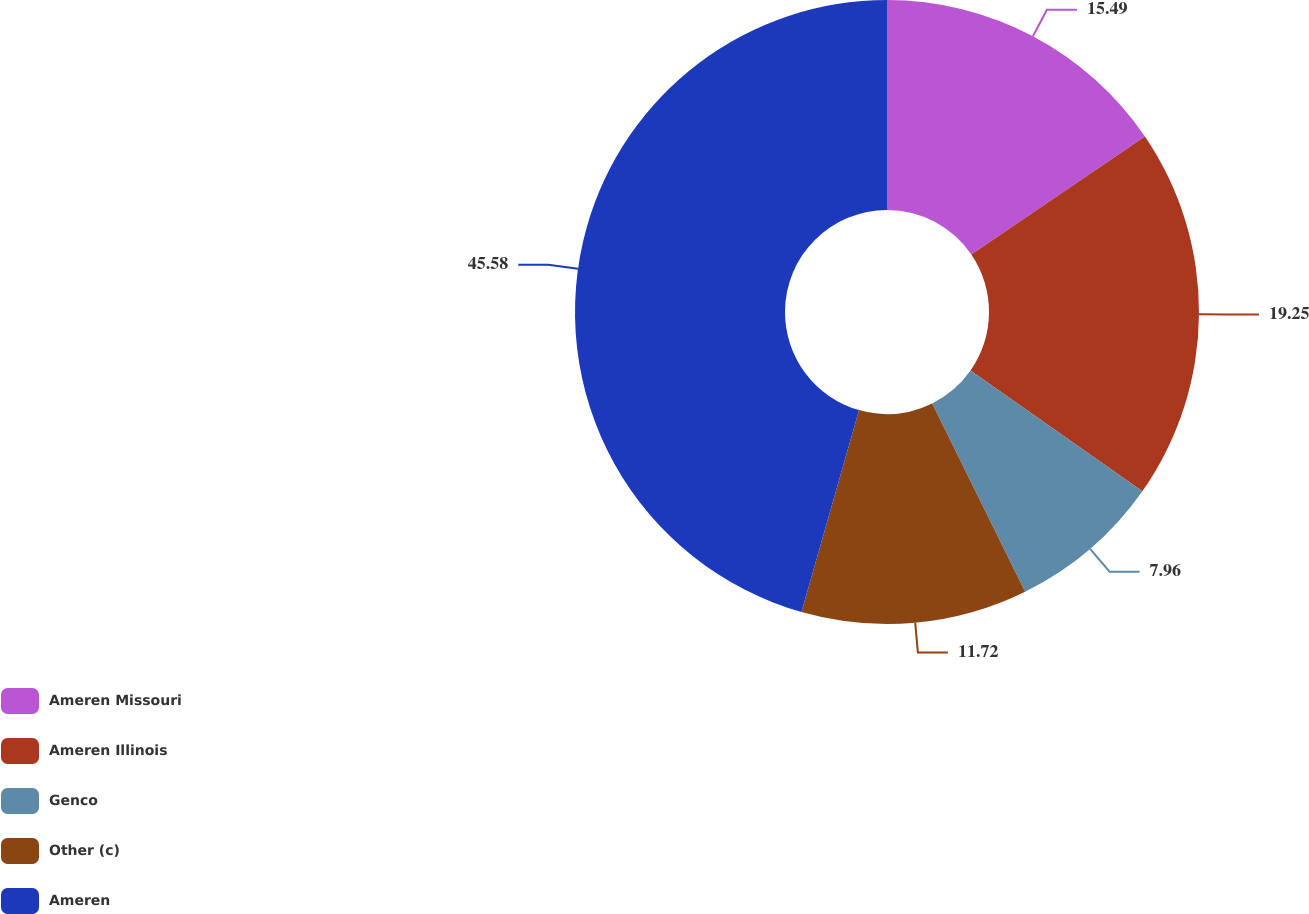Convert chart. <chart><loc_0><loc_0><loc_500><loc_500><pie_chart><fcel>Ameren Missouri<fcel>Ameren Illinois<fcel>Genco<fcel>Other (c)<fcel>Ameren<nl><fcel>15.49%<fcel>19.25%<fcel>7.96%<fcel>11.72%<fcel>45.58%<nl></chart> 